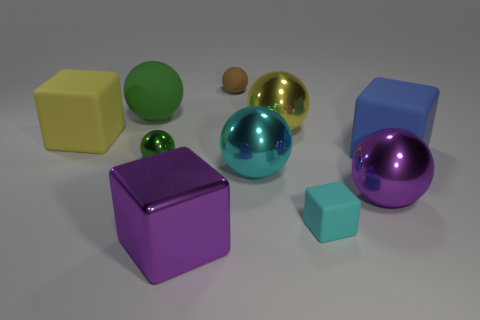Subtract all yellow spheres. How many spheres are left? 5 Subtract 1 blocks. How many blocks are left? 3 Subtract all brown matte spheres. How many spheres are left? 5 Subtract all purple cubes. Subtract all gray spheres. How many cubes are left? 3 Subtract all cubes. How many objects are left? 6 Add 5 big yellow metal things. How many big yellow metal things are left? 6 Add 7 big green blocks. How many big green blocks exist? 7 Subtract 1 brown balls. How many objects are left? 9 Subtract all blue matte blocks. Subtract all big green rubber objects. How many objects are left? 8 